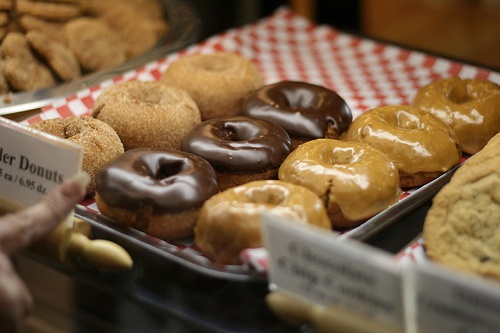Describe the objects in this image and their specific colors. I can see donut in olive, black, maroon, and darkgray tones, donut in olive, tan, and maroon tones, donut in olive, tan, and maroon tones, donut in olive, maroon, black, and gray tones, and donut in olive, orange, and tan tones in this image. 